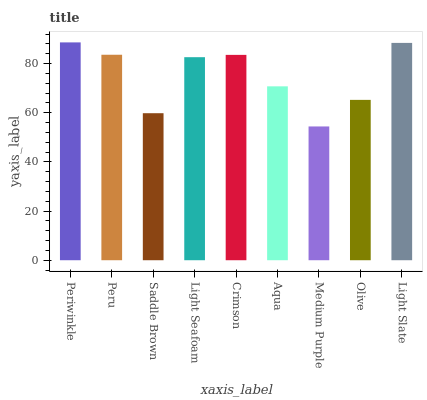Is Medium Purple the minimum?
Answer yes or no. Yes. Is Periwinkle the maximum?
Answer yes or no. Yes. Is Peru the minimum?
Answer yes or no. No. Is Peru the maximum?
Answer yes or no. No. Is Periwinkle greater than Peru?
Answer yes or no. Yes. Is Peru less than Periwinkle?
Answer yes or no. Yes. Is Peru greater than Periwinkle?
Answer yes or no. No. Is Periwinkle less than Peru?
Answer yes or no. No. Is Light Seafoam the high median?
Answer yes or no. Yes. Is Light Seafoam the low median?
Answer yes or no. Yes. Is Periwinkle the high median?
Answer yes or no. No. Is Medium Purple the low median?
Answer yes or no. No. 